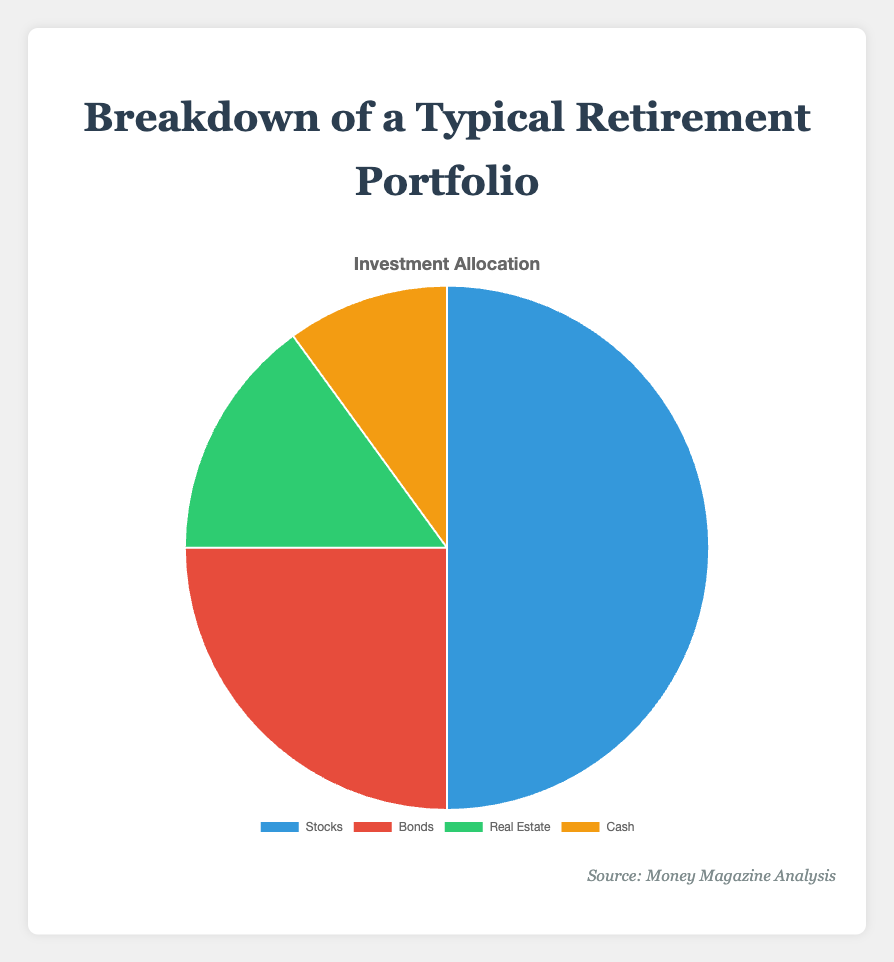What is the largest investment type in the portfolio? The pie chart shows four investment types: Stocks, Bonds, Real Estate, and Cash. By visually inspecting the chart, it is evident that Stocks occupy the largest portion of the pie.
Answer: Stocks What percentage of the portfolio is invested in Real Estate and Bonds combined? The pie chart indicates that Real Estate is 15% and Bonds are 25%. Adding these percentages together gives 15% + 25% = 40%.
Answer: 40% Which investment type has the smallest allocation? The pie chart shows the least amount of the pie is occupied by Cash, which is 10%.
Answer: Cash What is the percentage difference between the Stocks and Bonds allocations? According to the pie chart, Stocks are 50% and Bonds are 25%. The difference is calculated as 50% - 25% = 25%.
Answer: 25% How does the allocation of Cash compare to the allocation of Real Estate? The pie chart shows Cash is allocated 10% of the portfolio, whereas Real Estate is allocated 15%. Therefore, Cash has a smaller allocation compared to Real Estate.
Answer: Real Estate is larger What are the colors representing each investment type? The pie chart uses different colors for each investment type: Stocks are blue, Bonds are red, Real Estate is green, and Cash is yellow.
Answer: Stocks: blue, Bonds: red, Real Estate: green, Cash: yellow If the portfolio percentage for Cash increased by 5%, what would be the new percentage allocation for Cash? The current percentage for Cash is 10%. Adding an increase of 5% gives 10% + 5% = 15%.
Answer: 15% What is the total percentage allocated to Stocks and Cash? The pie chart indicates that Stocks are allocated 50% and Cash 10%. Summing these percentages gives 50% + 10% = 60%.
Answer: 60% 